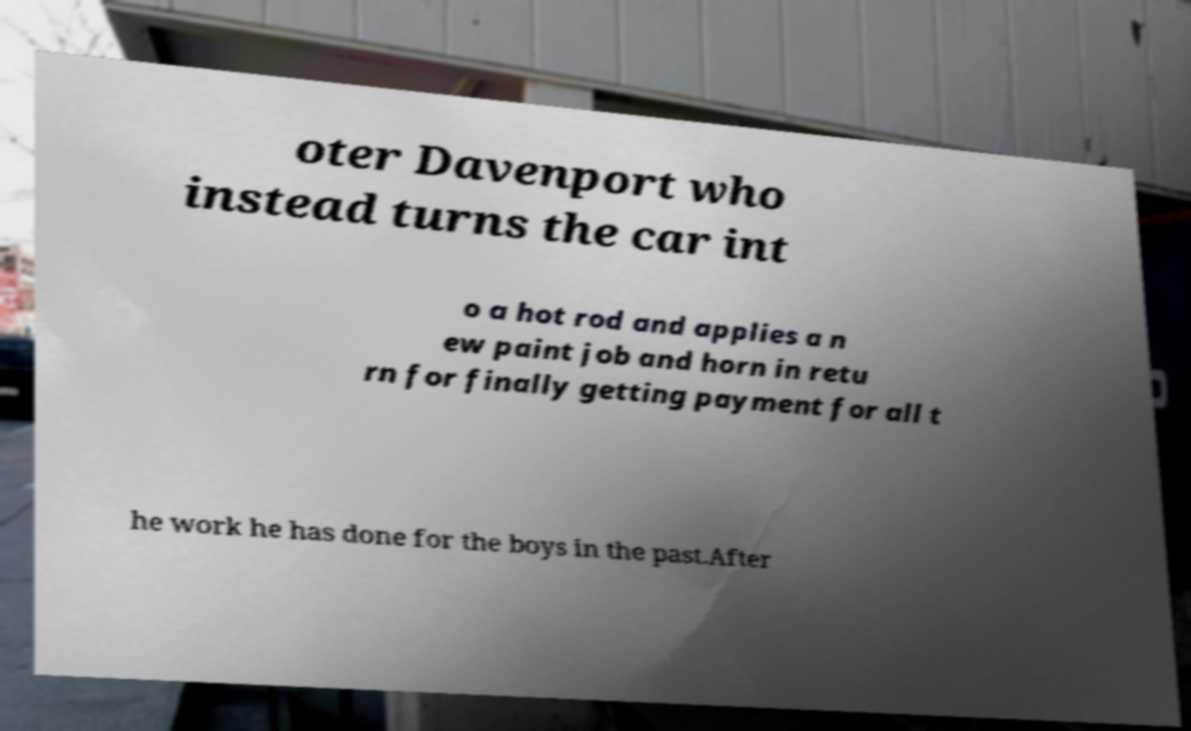Please identify and transcribe the text found in this image. oter Davenport who instead turns the car int o a hot rod and applies a n ew paint job and horn in retu rn for finally getting payment for all t he work he has done for the boys in the past.After 